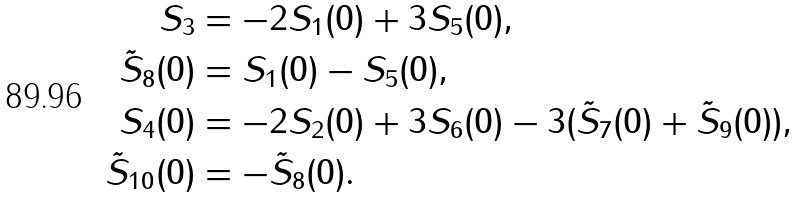Convert formula to latex. <formula><loc_0><loc_0><loc_500><loc_500>S _ { 3 } & = - 2 S _ { 1 } ( 0 ) + 3 S _ { 5 } ( 0 ) , \\ \tilde { S } _ { 8 } ( 0 ) & = S _ { 1 } ( 0 ) - S _ { 5 } ( 0 ) , \\ S _ { 4 } ( 0 ) & = - 2 S _ { 2 } ( 0 ) + 3 S _ { 6 } ( 0 ) - 3 ( \tilde { S } _ { 7 } ( 0 ) + \tilde { S } _ { 9 } ( 0 ) ) , \\ \tilde { S } _ { 1 0 } ( 0 ) & = - \tilde { S } _ { 8 } ( 0 ) .</formula> 